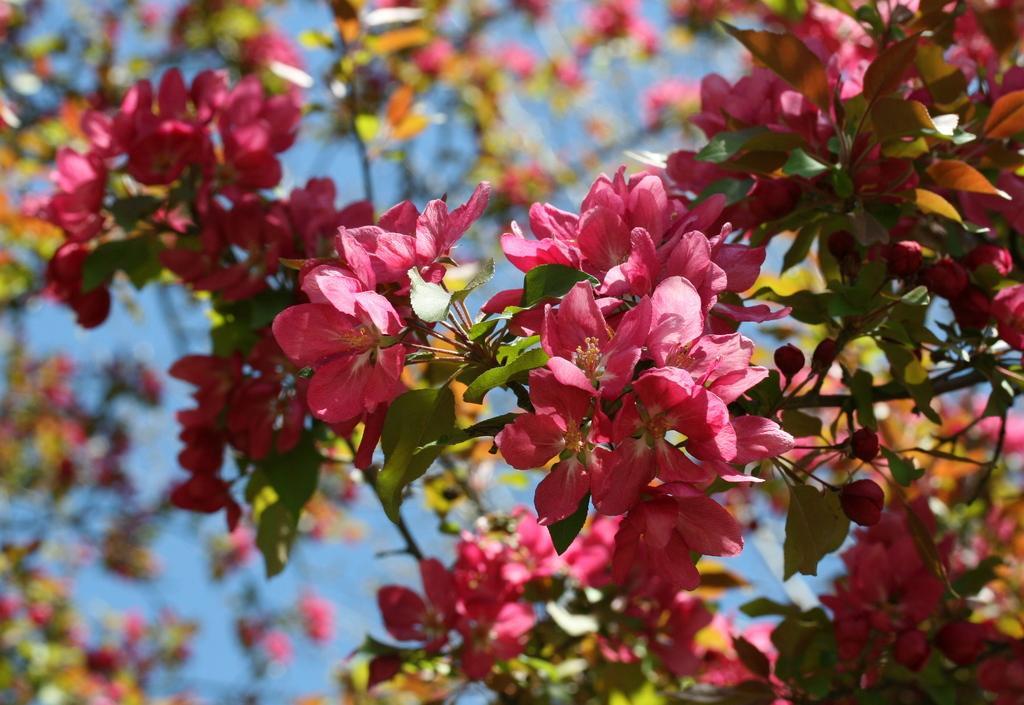Describe this image in one or two sentences. In this image there is a tree, there are flowers, the background of the image is blue in color. 